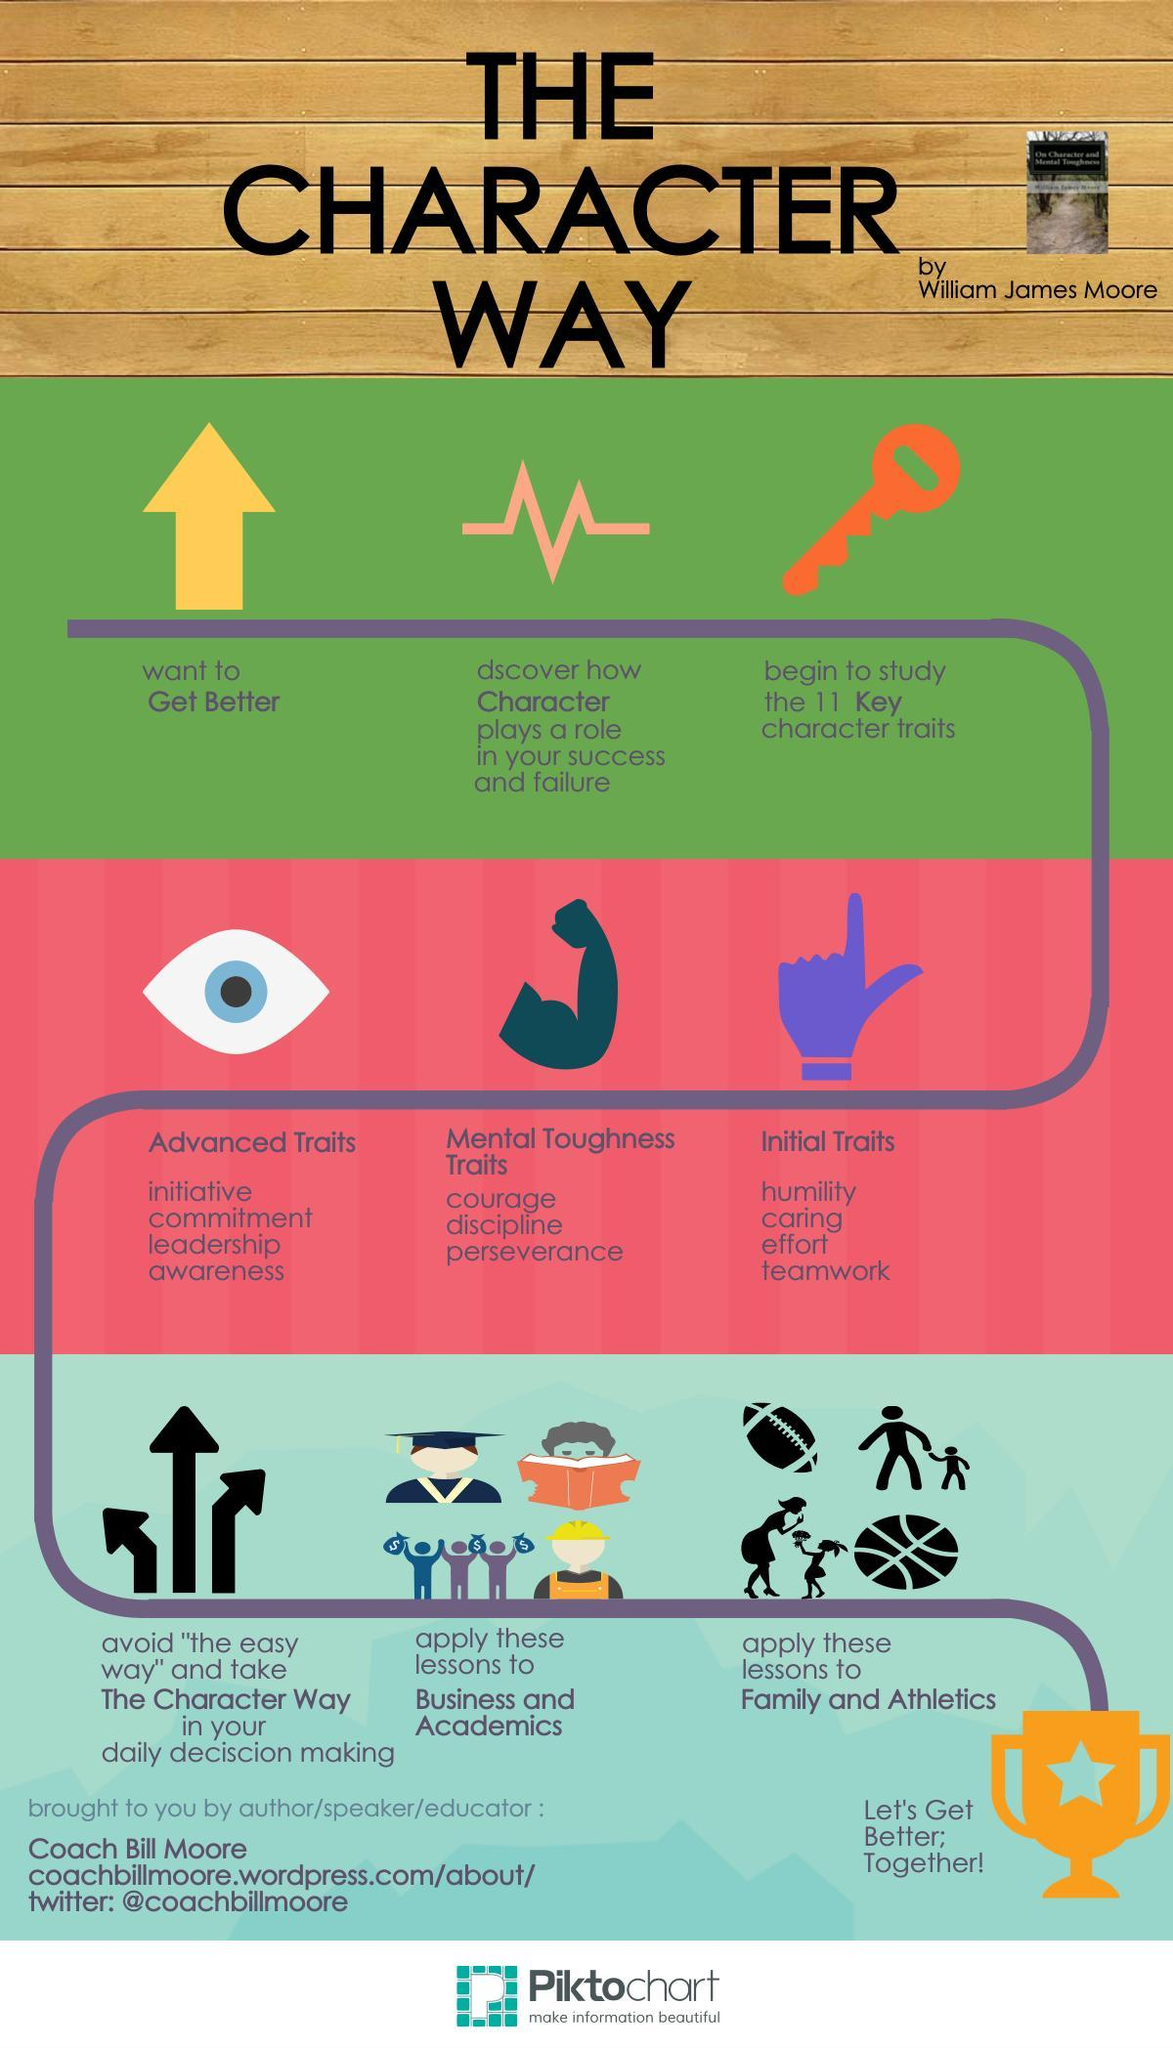Identify some key points in this picture. The infographic contains 4 arrows. 